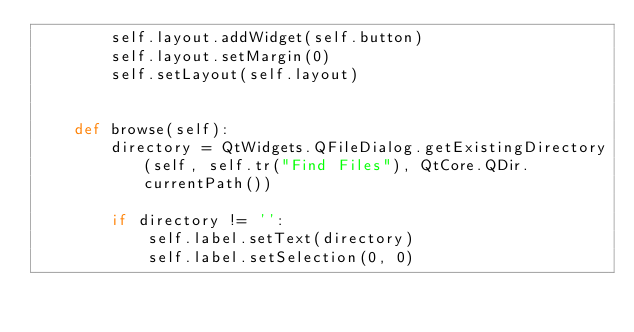<code> <loc_0><loc_0><loc_500><loc_500><_Python_>        self.layout.addWidget(self.button)
        self.layout.setMargin(0)
        self.setLayout(self.layout)


    def browse(self):
        directory = QtWidgets.QFileDialog.getExistingDirectory(self, self.tr("Find Files"), QtCore.QDir.currentPath())

        if directory != '':
            self.label.setText(directory)
            self.label.setSelection(0, 0)
</code> 